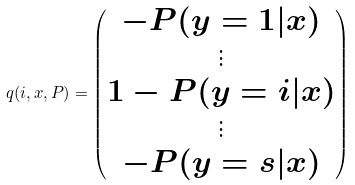Convert formula to latex. <formula><loc_0><loc_0><loc_500><loc_500>q ( i , x , P ) = \begin{pmatrix} - P ( y = 1 | x ) \\ \vdots \\ 1 - P ( y = i | x ) \\ \vdots \\ - P ( y = s | x ) \end{pmatrix}</formula> 